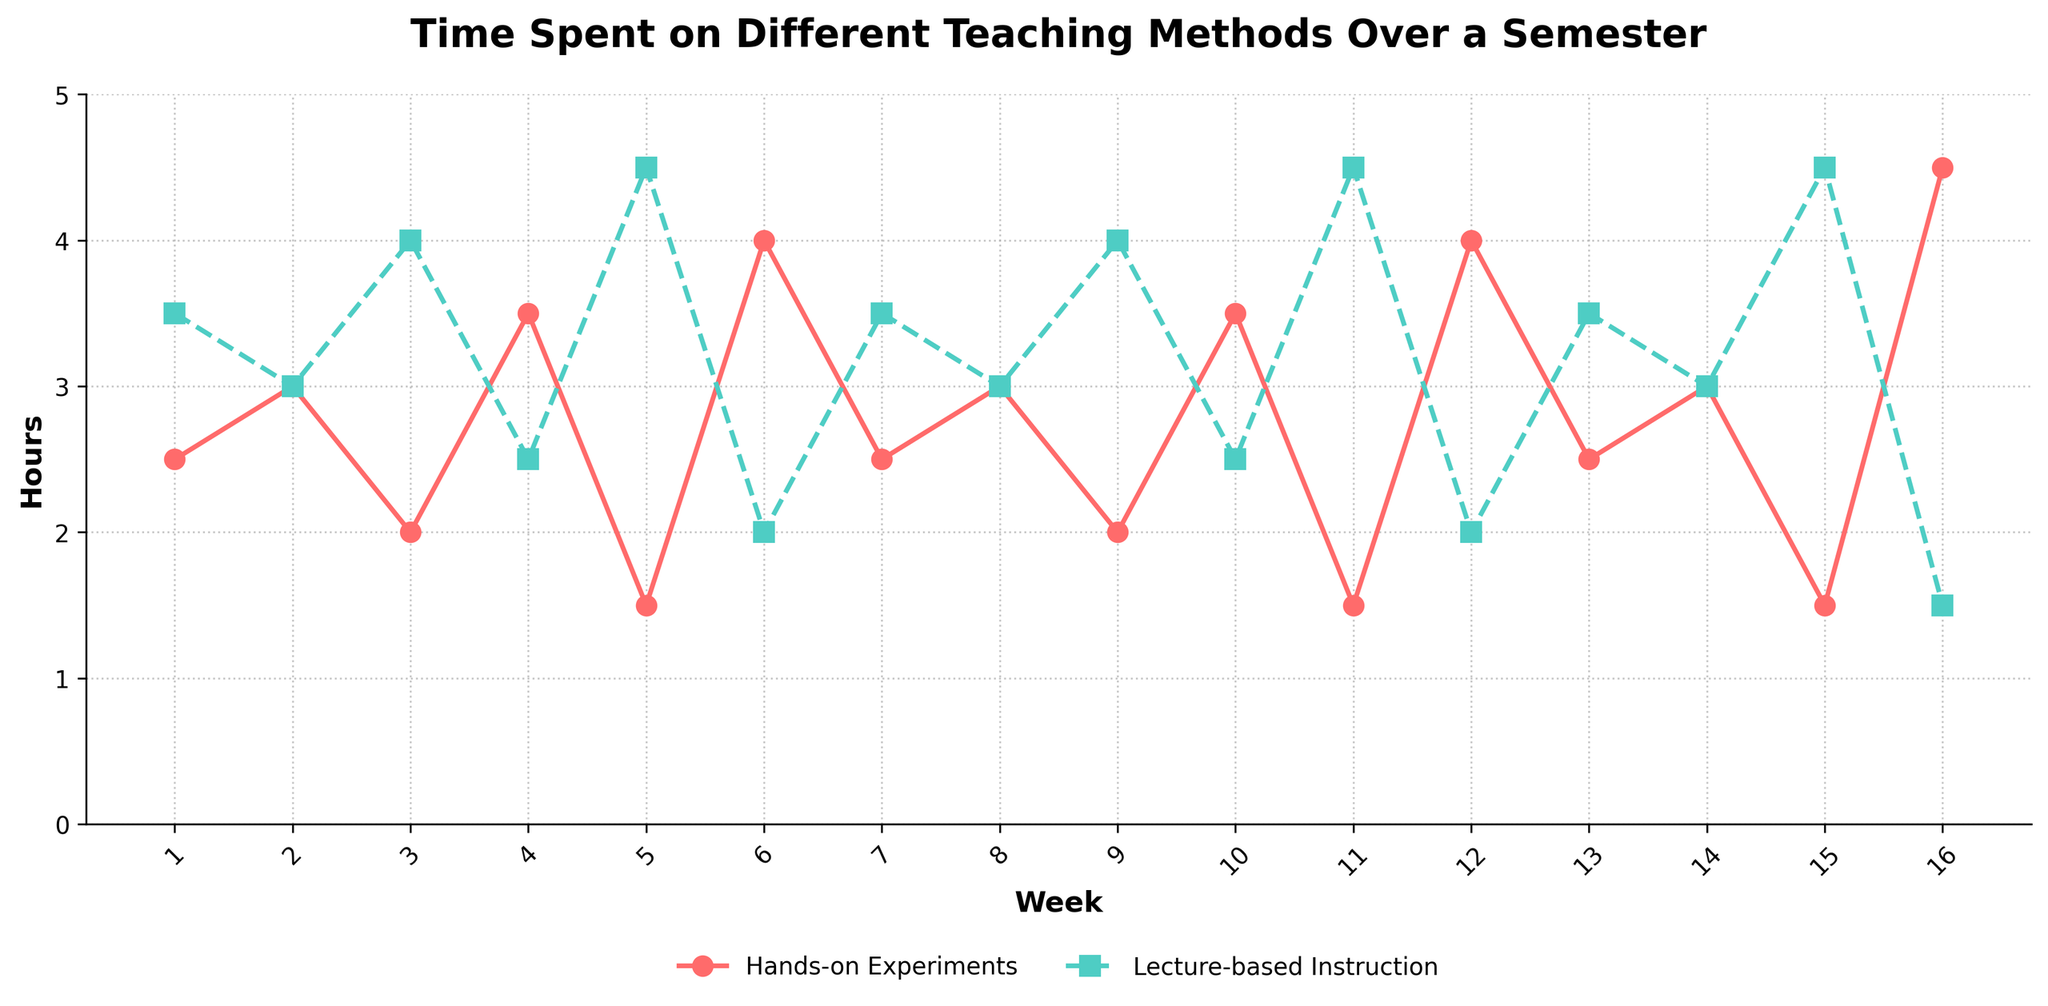What is the highest number of hours spent on hands-on experiments in any given week? By observing the plot line for hands-on experiments, we see the peak point at Week 16 with 4.5 hours.
Answer: 4.5 Which week had the same amount of time spent on both hands-on experiments and lecture-based instruction? We need to find where the lines for both hands-on experiments and lecture-based instruction intersect. This occurs at Week 2, Week 8, and Week 14, all showing 3.0 hours for both activities.
Answer: Week 2, Week 8, Week 14 Which teaching method dominates in Week 5? In the plot, the hands-on experiments line is at 1.5 hours while the lecture-based instruction line is at 4.5 hours in Week 5, making lecture-based instruction the dominant method.
Answer: Lecture-based Instruction What is the total time devoted to hands-on experiments and lecture-based instruction in Week 10? From the plot, hands-on experiments are marked at 3.5 hours and lecture-based instruction at 2.5 hours in Week 10. Summing these gives 3.5 + 2.5 = 6.0 hours.
Answer: 6.0 During which week is the gap between hours spent on lecture-based instruction and hands-on experiments the largest? We look for the greatest vertical distance between the two lines for any week. At Week 11 (Lecture: 4.5, Hands-on: 1.5), the gap is 4.5 - 1.5 = 3.0 hours, the largest observed difference.
Answer: Week 11 Compare the trend of hands-on experiments and lecture-based instruction from Week 1 to Week 16. Which method shows more variability over the semester? The hands-on experiments line fluctuates substantially, ranging from 1.5 to 4.5 hours. The lecture-based instruction line shows less variability, mostly between 2.0 and 4.5 hours but generally reducing.
Answer: Hands-on Experiments In the first half of the semester (Weeks 1-8), is the mean time spent on hands-on experiments higher or lower than the mean time spent on lecture-based instruction? Calculate the mean for both methods between Weeks 1-8. Hands-on experiments: (2.5 + 3.0 + 2.0 + 3.5 + 1.5 + 4.0 + 2.5 + 3.0) / 8 = 2.75 hours. Lecture-based: (3.5 + 3.0 + 4.0 + 2.5 + 4.5 + 2.0 + 3.5 + 3.0) / 8 = 3.25 hours. Thus, hands-on experiments have a lower mean.
Answer: Lower 